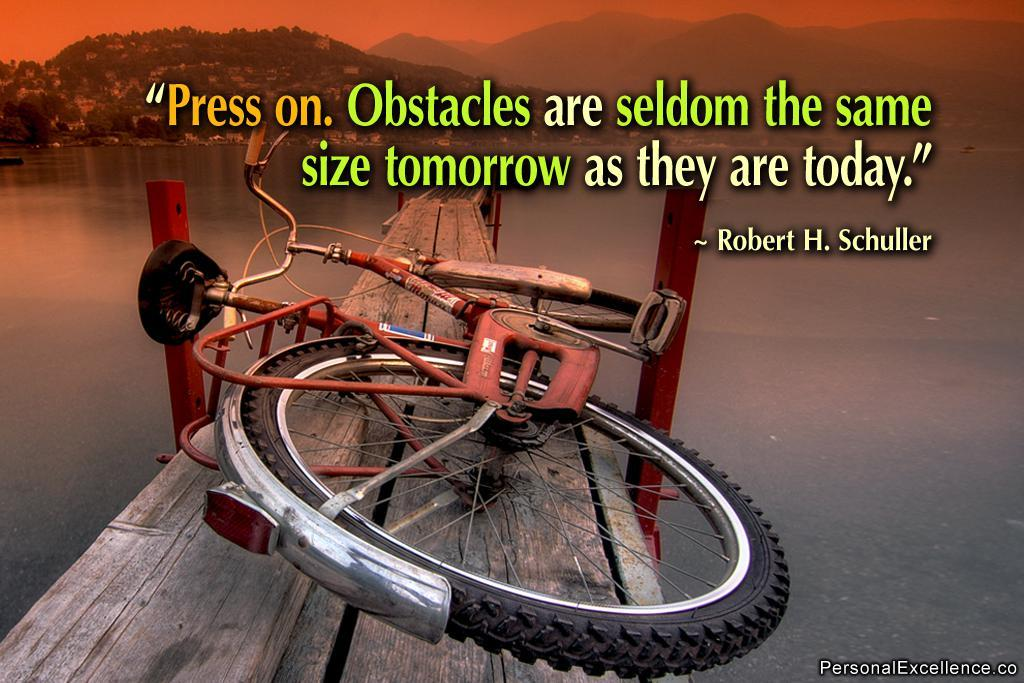What is the main object in the image? There is a bicycle in the image. Where is the bicycle located? The bicycle is on a wooden bridge. What can be seen in the background of the image? There is water and hills visible in the background of the image. Are there any visible imperfections on the image? Yes, there are watermarks on the image. What type of trousers is the bicycle wearing in the image? The bicycle is an inanimate object and does not wear trousers. How is the wire used in the image? There is no wire present in the image. 